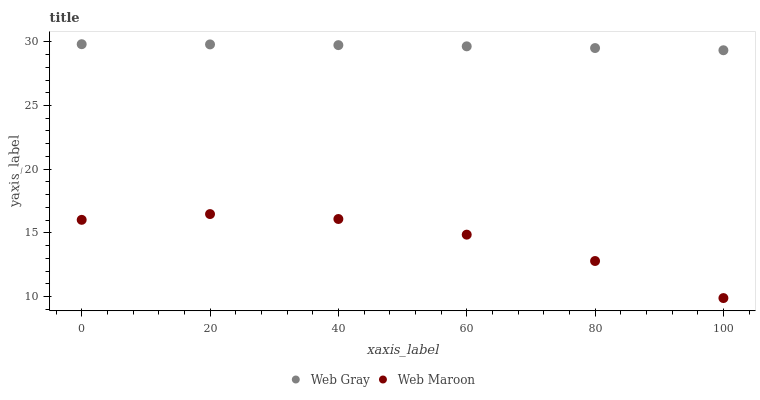Does Web Maroon have the minimum area under the curve?
Answer yes or no. Yes. Does Web Gray have the maximum area under the curve?
Answer yes or no. Yes. Does Web Maroon have the maximum area under the curve?
Answer yes or no. No. Is Web Gray the smoothest?
Answer yes or no. Yes. Is Web Maroon the roughest?
Answer yes or no. Yes. Is Web Maroon the smoothest?
Answer yes or no. No. Does Web Maroon have the lowest value?
Answer yes or no. Yes. Does Web Gray have the highest value?
Answer yes or no. Yes. Does Web Maroon have the highest value?
Answer yes or no. No. Is Web Maroon less than Web Gray?
Answer yes or no. Yes. Is Web Gray greater than Web Maroon?
Answer yes or no. Yes. Does Web Maroon intersect Web Gray?
Answer yes or no. No. 